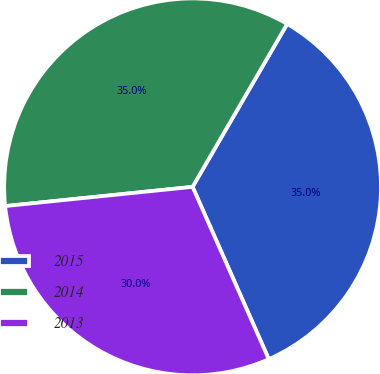Convert chart. <chart><loc_0><loc_0><loc_500><loc_500><pie_chart><fcel>2015<fcel>2014<fcel>2013<nl><fcel>35.0%<fcel>35.0%<fcel>30.0%<nl></chart> 